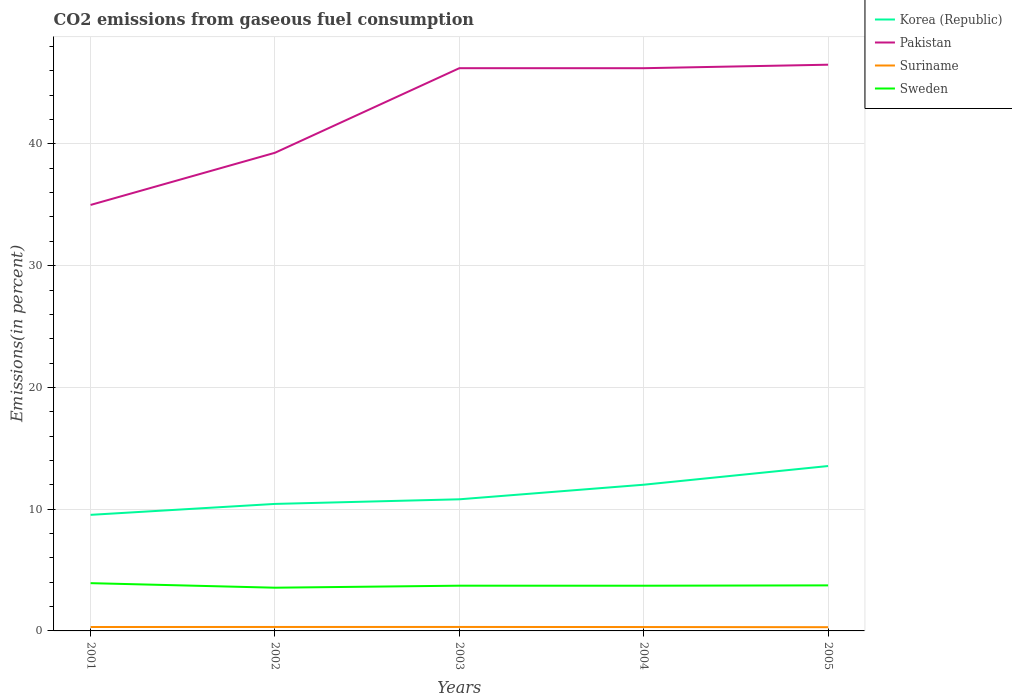How many different coloured lines are there?
Provide a short and direct response. 4. Does the line corresponding to Korea (Republic) intersect with the line corresponding to Suriname?
Provide a short and direct response. No. Across all years, what is the maximum total CO2 emitted in Korea (Republic)?
Keep it short and to the point. 9.53. What is the total total CO2 emitted in Pakistan in the graph?
Your answer should be very brief. -0.29. What is the difference between the highest and the second highest total CO2 emitted in Suriname?
Provide a succinct answer. 0.02. What is the difference between two consecutive major ticks on the Y-axis?
Offer a terse response. 10. Does the graph contain any zero values?
Provide a short and direct response. No. Where does the legend appear in the graph?
Your answer should be compact. Top right. How are the legend labels stacked?
Give a very brief answer. Vertical. What is the title of the graph?
Provide a short and direct response. CO2 emissions from gaseous fuel consumption. Does "Central African Republic" appear as one of the legend labels in the graph?
Your response must be concise. No. What is the label or title of the X-axis?
Offer a terse response. Years. What is the label or title of the Y-axis?
Your response must be concise. Emissions(in percent). What is the Emissions(in percent) of Korea (Republic) in 2001?
Give a very brief answer. 9.53. What is the Emissions(in percent) in Pakistan in 2001?
Your answer should be compact. 34.99. What is the Emissions(in percent) in Suriname in 2001?
Your answer should be very brief. 0.32. What is the Emissions(in percent) in Sweden in 2001?
Keep it short and to the point. 3.92. What is the Emissions(in percent) of Korea (Republic) in 2002?
Offer a terse response. 10.43. What is the Emissions(in percent) in Pakistan in 2002?
Your answer should be compact. 39.28. What is the Emissions(in percent) of Suriname in 2002?
Provide a succinct answer. 0.32. What is the Emissions(in percent) in Sweden in 2002?
Offer a very short reply. 3.55. What is the Emissions(in percent) of Korea (Republic) in 2003?
Keep it short and to the point. 10.81. What is the Emissions(in percent) in Pakistan in 2003?
Your answer should be very brief. 46.22. What is the Emissions(in percent) in Suriname in 2003?
Your answer should be compact. 0.33. What is the Emissions(in percent) of Sweden in 2003?
Offer a very short reply. 3.72. What is the Emissions(in percent) in Korea (Republic) in 2004?
Provide a succinct answer. 12.01. What is the Emissions(in percent) in Pakistan in 2004?
Provide a short and direct response. 46.22. What is the Emissions(in percent) in Suriname in 2004?
Provide a short and direct response. 0.32. What is the Emissions(in percent) in Sweden in 2004?
Your answer should be very brief. 3.71. What is the Emissions(in percent) of Korea (Republic) in 2005?
Give a very brief answer. 13.54. What is the Emissions(in percent) in Pakistan in 2005?
Make the answer very short. 46.51. What is the Emissions(in percent) in Suriname in 2005?
Your response must be concise. 0.31. What is the Emissions(in percent) of Sweden in 2005?
Provide a short and direct response. 3.74. Across all years, what is the maximum Emissions(in percent) of Korea (Republic)?
Offer a very short reply. 13.54. Across all years, what is the maximum Emissions(in percent) in Pakistan?
Your response must be concise. 46.51. Across all years, what is the maximum Emissions(in percent) of Suriname?
Keep it short and to the point. 0.33. Across all years, what is the maximum Emissions(in percent) of Sweden?
Provide a short and direct response. 3.92. Across all years, what is the minimum Emissions(in percent) of Korea (Republic)?
Provide a succinct answer. 9.53. Across all years, what is the minimum Emissions(in percent) in Pakistan?
Your answer should be compact. 34.99. Across all years, what is the minimum Emissions(in percent) in Suriname?
Give a very brief answer. 0.31. Across all years, what is the minimum Emissions(in percent) in Sweden?
Ensure brevity in your answer.  3.55. What is the total Emissions(in percent) of Korea (Republic) in the graph?
Your response must be concise. 56.33. What is the total Emissions(in percent) of Pakistan in the graph?
Provide a succinct answer. 213.22. What is the total Emissions(in percent) in Suriname in the graph?
Your answer should be very brief. 1.6. What is the total Emissions(in percent) in Sweden in the graph?
Provide a short and direct response. 18.64. What is the difference between the Emissions(in percent) in Korea (Republic) in 2001 and that in 2002?
Ensure brevity in your answer.  -0.9. What is the difference between the Emissions(in percent) of Pakistan in 2001 and that in 2002?
Offer a terse response. -4.29. What is the difference between the Emissions(in percent) of Suriname in 2001 and that in 2002?
Offer a terse response. -0. What is the difference between the Emissions(in percent) of Sweden in 2001 and that in 2002?
Provide a short and direct response. 0.37. What is the difference between the Emissions(in percent) of Korea (Republic) in 2001 and that in 2003?
Provide a succinct answer. -1.28. What is the difference between the Emissions(in percent) of Pakistan in 2001 and that in 2003?
Your answer should be very brief. -11.23. What is the difference between the Emissions(in percent) of Suriname in 2001 and that in 2003?
Offer a very short reply. -0. What is the difference between the Emissions(in percent) of Sweden in 2001 and that in 2003?
Keep it short and to the point. 0.21. What is the difference between the Emissions(in percent) of Korea (Republic) in 2001 and that in 2004?
Provide a short and direct response. -2.47. What is the difference between the Emissions(in percent) of Pakistan in 2001 and that in 2004?
Provide a succinct answer. -11.23. What is the difference between the Emissions(in percent) in Suriname in 2001 and that in 2004?
Your answer should be very brief. 0. What is the difference between the Emissions(in percent) in Sweden in 2001 and that in 2004?
Your answer should be compact. 0.21. What is the difference between the Emissions(in percent) in Korea (Republic) in 2001 and that in 2005?
Ensure brevity in your answer.  -4.01. What is the difference between the Emissions(in percent) in Pakistan in 2001 and that in 2005?
Give a very brief answer. -11.52. What is the difference between the Emissions(in percent) in Suriname in 2001 and that in 2005?
Keep it short and to the point. 0.02. What is the difference between the Emissions(in percent) of Sweden in 2001 and that in 2005?
Your answer should be compact. 0.18. What is the difference between the Emissions(in percent) of Korea (Republic) in 2002 and that in 2003?
Provide a succinct answer. -0.38. What is the difference between the Emissions(in percent) of Pakistan in 2002 and that in 2003?
Ensure brevity in your answer.  -6.95. What is the difference between the Emissions(in percent) in Suriname in 2002 and that in 2003?
Provide a short and direct response. -0. What is the difference between the Emissions(in percent) of Sweden in 2002 and that in 2003?
Your answer should be compact. -0.16. What is the difference between the Emissions(in percent) of Korea (Republic) in 2002 and that in 2004?
Your answer should be very brief. -1.58. What is the difference between the Emissions(in percent) in Pakistan in 2002 and that in 2004?
Provide a short and direct response. -6.95. What is the difference between the Emissions(in percent) in Suriname in 2002 and that in 2004?
Ensure brevity in your answer.  0.01. What is the difference between the Emissions(in percent) in Sweden in 2002 and that in 2004?
Keep it short and to the point. -0.16. What is the difference between the Emissions(in percent) of Korea (Republic) in 2002 and that in 2005?
Keep it short and to the point. -3.11. What is the difference between the Emissions(in percent) in Pakistan in 2002 and that in 2005?
Keep it short and to the point. -7.23. What is the difference between the Emissions(in percent) in Suriname in 2002 and that in 2005?
Offer a terse response. 0.02. What is the difference between the Emissions(in percent) of Sweden in 2002 and that in 2005?
Provide a succinct answer. -0.19. What is the difference between the Emissions(in percent) in Korea (Republic) in 2003 and that in 2004?
Ensure brevity in your answer.  -1.2. What is the difference between the Emissions(in percent) of Pakistan in 2003 and that in 2004?
Offer a very short reply. 0. What is the difference between the Emissions(in percent) in Suriname in 2003 and that in 2004?
Your answer should be compact. 0.01. What is the difference between the Emissions(in percent) in Sweden in 2003 and that in 2004?
Provide a succinct answer. 0. What is the difference between the Emissions(in percent) in Korea (Republic) in 2003 and that in 2005?
Offer a terse response. -2.73. What is the difference between the Emissions(in percent) in Pakistan in 2003 and that in 2005?
Offer a terse response. -0.29. What is the difference between the Emissions(in percent) in Suriname in 2003 and that in 2005?
Provide a short and direct response. 0.02. What is the difference between the Emissions(in percent) in Sweden in 2003 and that in 2005?
Your answer should be compact. -0.03. What is the difference between the Emissions(in percent) of Korea (Republic) in 2004 and that in 2005?
Your answer should be very brief. -1.53. What is the difference between the Emissions(in percent) in Pakistan in 2004 and that in 2005?
Give a very brief answer. -0.29. What is the difference between the Emissions(in percent) in Suriname in 2004 and that in 2005?
Make the answer very short. 0.01. What is the difference between the Emissions(in percent) in Sweden in 2004 and that in 2005?
Give a very brief answer. -0.03. What is the difference between the Emissions(in percent) of Korea (Republic) in 2001 and the Emissions(in percent) of Pakistan in 2002?
Offer a terse response. -29.74. What is the difference between the Emissions(in percent) in Korea (Republic) in 2001 and the Emissions(in percent) in Suriname in 2002?
Offer a very short reply. 9.21. What is the difference between the Emissions(in percent) of Korea (Republic) in 2001 and the Emissions(in percent) of Sweden in 2002?
Your response must be concise. 5.98. What is the difference between the Emissions(in percent) of Pakistan in 2001 and the Emissions(in percent) of Suriname in 2002?
Give a very brief answer. 34.66. What is the difference between the Emissions(in percent) in Pakistan in 2001 and the Emissions(in percent) in Sweden in 2002?
Your response must be concise. 31.44. What is the difference between the Emissions(in percent) in Suriname in 2001 and the Emissions(in percent) in Sweden in 2002?
Your response must be concise. -3.23. What is the difference between the Emissions(in percent) of Korea (Republic) in 2001 and the Emissions(in percent) of Pakistan in 2003?
Provide a succinct answer. -36.69. What is the difference between the Emissions(in percent) of Korea (Republic) in 2001 and the Emissions(in percent) of Suriname in 2003?
Provide a succinct answer. 9.21. What is the difference between the Emissions(in percent) of Korea (Republic) in 2001 and the Emissions(in percent) of Sweden in 2003?
Keep it short and to the point. 5.82. What is the difference between the Emissions(in percent) of Pakistan in 2001 and the Emissions(in percent) of Suriname in 2003?
Provide a short and direct response. 34.66. What is the difference between the Emissions(in percent) in Pakistan in 2001 and the Emissions(in percent) in Sweden in 2003?
Your answer should be compact. 31.27. What is the difference between the Emissions(in percent) of Suriname in 2001 and the Emissions(in percent) of Sweden in 2003?
Your answer should be very brief. -3.39. What is the difference between the Emissions(in percent) in Korea (Republic) in 2001 and the Emissions(in percent) in Pakistan in 2004?
Your answer should be very brief. -36.69. What is the difference between the Emissions(in percent) of Korea (Republic) in 2001 and the Emissions(in percent) of Suriname in 2004?
Provide a succinct answer. 9.22. What is the difference between the Emissions(in percent) of Korea (Republic) in 2001 and the Emissions(in percent) of Sweden in 2004?
Make the answer very short. 5.82. What is the difference between the Emissions(in percent) of Pakistan in 2001 and the Emissions(in percent) of Suriname in 2004?
Offer a very short reply. 34.67. What is the difference between the Emissions(in percent) in Pakistan in 2001 and the Emissions(in percent) in Sweden in 2004?
Your response must be concise. 31.28. What is the difference between the Emissions(in percent) of Suriname in 2001 and the Emissions(in percent) of Sweden in 2004?
Provide a short and direct response. -3.39. What is the difference between the Emissions(in percent) of Korea (Republic) in 2001 and the Emissions(in percent) of Pakistan in 2005?
Keep it short and to the point. -36.97. What is the difference between the Emissions(in percent) in Korea (Republic) in 2001 and the Emissions(in percent) in Suriname in 2005?
Keep it short and to the point. 9.23. What is the difference between the Emissions(in percent) of Korea (Republic) in 2001 and the Emissions(in percent) of Sweden in 2005?
Your answer should be compact. 5.79. What is the difference between the Emissions(in percent) of Pakistan in 2001 and the Emissions(in percent) of Suriname in 2005?
Provide a succinct answer. 34.68. What is the difference between the Emissions(in percent) of Pakistan in 2001 and the Emissions(in percent) of Sweden in 2005?
Provide a short and direct response. 31.25. What is the difference between the Emissions(in percent) in Suriname in 2001 and the Emissions(in percent) in Sweden in 2005?
Ensure brevity in your answer.  -3.42. What is the difference between the Emissions(in percent) in Korea (Republic) in 2002 and the Emissions(in percent) in Pakistan in 2003?
Your response must be concise. -35.79. What is the difference between the Emissions(in percent) of Korea (Republic) in 2002 and the Emissions(in percent) of Suriname in 2003?
Your answer should be compact. 10.11. What is the difference between the Emissions(in percent) of Korea (Republic) in 2002 and the Emissions(in percent) of Sweden in 2003?
Keep it short and to the point. 6.72. What is the difference between the Emissions(in percent) of Pakistan in 2002 and the Emissions(in percent) of Suriname in 2003?
Offer a terse response. 38.95. What is the difference between the Emissions(in percent) of Pakistan in 2002 and the Emissions(in percent) of Sweden in 2003?
Provide a short and direct response. 35.56. What is the difference between the Emissions(in percent) in Suriname in 2002 and the Emissions(in percent) in Sweden in 2003?
Offer a very short reply. -3.39. What is the difference between the Emissions(in percent) in Korea (Republic) in 2002 and the Emissions(in percent) in Pakistan in 2004?
Make the answer very short. -35.79. What is the difference between the Emissions(in percent) in Korea (Republic) in 2002 and the Emissions(in percent) in Suriname in 2004?
Give a very brief answer. 10.11. What is the difference between the Emissions(in percent) in Korea (Republic) in 2002 and the Emissions(in percent) in Sweden in 2004?
Give a very brief answer. 6.72. What is the difference between the Emissions(in percent) in Pakistan in 2002 and the Emissions(in percent) in Suriname in 2004?
Offer a very short reply. 38.96. What is the difference between the Emissions(in percent) of Pakistan in 2002 and the Emissions(in percent) of Sweden in 2004?
Offer a very short reply. 35.56. What is the difference between the Emissions(in percent) of Suriname in 2002 and the Emissions(in percent) of Sweden in 2004?
Make the answer very short. -3.39. What is the difference between the Emissions(in percent) of Korea (Republic) in 2002 and the Emissions(in percent) of Pakistan in 2005?
Offer a terse response. -36.08. What is the difference between the Emissions(in percent) in Korea (Republic) in 2002 and the Emissions(in percent) in Suriname in 2005?
Make the answer very short. 10.13. What is the difference between the Emissions(in percent) of Korea (Republic) in 2002 and the Emissions(in percent) of Sweden in 2005?
Make the answer very short. 6.69. What is the difference between the Emissions(in percent) in Pakistan in 2002 and the Emissions(in percent) in Suriname in 2005?
Ensure brevity in your answer.  38.97. What is the difference between the Emissions(in percent) of Pakistan in 2002 and the Emissions(in percent) of Sweden in 2005?
Your answer should be compact. 35.53. What is the difference between the Emissions(in percent) in Suriname in 2002 and the Emissions(in percent) in Sweden in 2005?
Offer a very short reply. -3.42. What is the difference between the Emissions(in percent) of Korea (Republic) in 2003 and the Emissions(in percent) of Pakistan in 2004?
Your answer should be compact. -35.41. What is the difference between the Emissions(in percent) in Korea (Republic) in 2003 and the Emissions(in percent) in Suriname in 2004?
Your answer should be very brief. 10.49. What is the difference between the Emissions(in percent) of Korea (Republic) in 2003 and the Emissions(in percent) of Sweden in 2004?
Your answer should be very brief. 7.1. What is the difference between the Emissions(in percent) in Pakistan in 2003 and the Emissions(in percent) in Suriname in 2004?
Provide a short and direct response. 45.9. What is the difference between the Emissions(in percent) of Pakistan in 2003 and the Emissions(in percent) of Sweden in 2004?
Provide a succinct answer. 42.51. What is the difference between the Emissions(in percent) in Suriname in 2003 and the Emissions(in percent) in Sweden in 2004?
Provide a short and direct response. -3.39. What is the difference between the Emissions(in percent) in Korea (Republic) in 2003 and the Emissions(in percent) in Pakistan in 2005?
Provide a succinct answer. -35.7. What is the difference between the Emissions(in percent) of Korea (Republic) in 2003 and the Emissions(in percent) of Suriname in 2005?
Your answer should be very brief. 10.5. What is the difference between the Emissions(in percent) in Korea (Republic) in 2003 and the Emissions(in percent) in Sweden in 2005?
Keep it short and to the point. 7.07. What is the difference between the Emissions(in percent) of Pakistan in 2003 and the Emissions(in percent) of Suriname in 2005?
Provide a succinct answer. 45.92. What is the difference between the Emissions(in percent) in Pakistan in 2003 and the Emissions(in percent) in Sweden in 2005?
Provide a short and direct response. 42.48. What is the difference between the Emissions(in percent) in Suriname in 2003 and the Emissions(in percent) in Sweden in 2005?
Offer a very short reply. -3.41. What is the difference between the Emissions(in percent) in Korea (Republic) in 2004 and the Emissions(in percent) in Pakistan in 2005?
Keep it short and to the point. -34.5. What is the difference between the Emissions(in percent) of Korea (Republic) in 2004 and the Emissions(in percent) of Suriname in 2005?
Provide a short and direct response. 11.7. What is the difference between the Emissions(in percent) of Korea (Republic) in 2004 and the Emissions(in percent) of Sweden in 2005?
Make the answer very short. 8.27. What is the difference between the Emissions(in percent) in Pakistan in 2004 and the Emissions(in percent) in Suriname in 2005?
Make the answer very short. 45.91. What is the difference between the Emissions(in percent) in Pakistan in 2004 and the Emissions(in percent) in Sweden in 2005?
Give a very brief answer. 42.48. What is the difference between the Emissions(in percent) of Suriname in 2004 and the Emissions(in percent) of Sweden in 2005?
Your response must be concise. -3.42. What is the average Emissions(in percent) in Korea (Republic) per year?
Provide a short and direct response. 11.27. What is the average Emissions(in percent) of Pakistan per year?
Keep it short and to the point. 42.64. What is the average Emissions(in percent) of Suriname per year?
Offer a very short reply. 0.32. What is the average Emissions(in percent) of Sweden per year?
Make the answer very short. 3.73. In the year 2001, what is the difference between the Emissions(in percent) in Korea (Republic) and Emissions(in percent) in Pakistan?
Offer a very short reply. -25.45. In the year 2001, what is the difference between the Emissions(in percent) in Korea (Republic) and Emissions(in percent) in Suriname?
Provide a short and direct response. 9.21. In the year 2001, what is the difference between the Emissions(in percent) of Korea (Republic) and Emissions(in percent) of Sweden?
Your answer should be very brief. 5.61. In the year 2001, what is the difference between the Emissions(in percent) of Pakistan and Emissions(in percent) of Suriname?
Provide a short and direct response. 34.67. In the year 2001, what is the difference between the Emissions(in percent) in Pakistan and Emissions(in percent) in Sweden?
Give a very brief answer. 31.07. In the year 2001, what is the difference between the Emissions(in percent) of Suriname and Emissions(in percent) of Sweden?
Offer a very short reply. -3.6. In the year 2002, what is the difference between the Emissions(in percent) in Korea (Republic) and Emissions(in percent) in Pakistan?
Give a very brief answer. -28.84. In the year 2002, what is the difference between the Emissions(in percent) in Korea (Republic) and Emissions(in percent) in Suriname?
Provide a succinct answer. 10.11. In the year 2002, what is the difference between the Emissions(in percent) in Korea (Republic) and Emissions(in percent) in Sweden?
Your answer should be very brief. 6.88. In the year 2002, what is the difference between the Emissions(in percent) in Pakistan and Emissions(in percent) in Suriname?
Your response must be concise. 38.95. In the year 2002, what is the difference between the Emissions(in percent) in Pakistan and Emissions(in percent) in Sweden?
Your answer should be compact. 35.73. In the year 2002, what is the difference between the Emissions(in percent) in Suriname and Emissions(in percent) in Sweden?
Provide a short and direct response. -3.23. In the year 2003, what is the difference between the Emissions(in percent) in Korea (Republic) and Emissions(in percent) in Pakistan?
Keep it short and to the point. -35.41. In the year 2003, what is the difference between the Emissions(in percent) of Korea (Republic) and Emissions(in percent) of Suriname?
Your response must be concise. 10.48. In the year 2003, what is the difference between the Emissions(in percent) of Korea (Republic) and Emissions(in percent) of Sweden?
Make the answer very short. 7.1. In the year 2003, what is the difference between the Emissions(in percent) of Pakistan and Emissions(in percent) of Suriname?
Keep it short and to the point. 45.9. In the year 2003, what is the difference between the Emissions(in percent) of Pakistan and Emissions(in percent) of Sweden?
Offer a terse response. 42.51. In the year 2003, what is the difference between the Emissions(in percent) in Suriname and Emissions(in percent) in Sweden?
Provide a short and direct response. -3.39. In the year 2004, what is the difference between the Emissions(in percent) of Korea (Republic) and Emissions(in percent) of Pakistan?
Your answer should be compact. -34.21. In the year 2004, what is the difference between the Emissions(in percent) in Korea (Republic) and Emissions(in percent) in Suriname?
Ensure brevity in your answer.  11.69. In the year 2004, what is the difference between the Emissions(in percent) in Korea (Republic) and Emissions(in percent) in Sweden?
Make the answer very short. 8.3. In the year 2004, what is the difference between the Emissions(in percent) of Pakistan and Emissions(in percent) of Suriname?
Ensure brevity in your answer.  45.9. In the year 2004, what is the difference between the Emissions(in percent) of Pakistan and Emissions(in percent) of Sweden?
Offer a terse response. 42.51. In the year 2004, what is the difference between the Emissions(in percent) in Suriname and Emissions(in percent) in Sweden?
Provide a succinct answer. -3.39. In the year 2005, what is the difference between the Emissions(in percent) in Korea (Republic) and Emissions(in percent) in Pakistan?
Provide a short and direct response. -32.97. In the year 2005, what is the difference between the Emissions(in percent) in Korea (Republic) and Emissions(in percent) in Suriname?
Offer a terse response. 13.24. In the year 2005, what is the difference between the Emissions(in percent) in Korea (Republic) and Emissions(in percent) in Sweden?
Give a very brief answer. 9.8. In the year 2005, what is the difference between the Emissions(in percent) in Pakistan and Emissions(in percent) in Suriname?
Make the answer very short. 46.2. In the year 2005, what is the difference between the Emissions(in percent) in Pakistan and Emissions(in percent) in Sweden?
Give a very brief answer. 42.77. In the year 2005, what is the difference between the Emissions(in percent) of Suriname and Emissions(in percent) of Sweden?
Your response must be concise. -3.43. What is the ratio of the Emissions(in percent) in Korea (Republic) in 2001 to that in 2002?
Provide a succinct answer. 0.91. What is the ratio of the Emissions(in percent) in Pakistan in 2001 to that in 2002?
Give a very brief answer. 0.89. What is the ratio of the Emissions(in percent) in Suriname in 2001 to that in 2002?
Ensure brevity in your answer.  0.99. What is the ratio of the Emissions(in percent) of Sweden in 2001 to that in 2002?
Provide a short and direct response. 1.1. What is the ratio of the Emissions(in percent) in Korea (Republic) in 2001 to that in 2003?
Your answer should be very brief. 0.88. What is the ratio of the Emissions(in percent) of Pakistan in 2001 to that in 2003?
Provide a short and direct response. 0.76. What is the ratio of the Emissions(in percent) in Suriname in 2001 to that in 2003?
Offer a terse response. 0.99. What is the ratio of the Emissions(in percent) of Sweden in 2001 to that in 2003?
Ensure brevity in your answer.  1.06. What is the ratio of the Emissions(in percent) of Korea (Republic) in 2001 to that in 2004?
Provide a succinct answer. 0.79. What is the ratio of the Emissions(in percent) of Pakistan in 2001 to that in 2004?
Offer a very short reply. 0.76. What is the ratio of the Emissions(in percent) in Suriname in 2001 to that in 2004?
Your response must be concise. 1.01. What is the ratio of the Emissions(in percent) in Sweden in 2001 to that in 2004?
Offer a very short reply. 1.06. What is the ratio of the Emissions(in percent) in Korea (Republic) in 2001 to that in 2005?
Your response must be concise. 0.7. What is the ratio of the Emissions(in percent) in Pakistan in 2001 to that in 2005?
Your response must be concise. 0.75. What is the ratio of the Emissions(in percent) in Sweden in 2001 to that in 2005?
Make the answer very short. 1.05. What is the ratio of the Emissions(in percent) in Korea (Republic) in 2002 to that in 2003?
Keep it short and to the point. 0.96. What is the ratio of the Emissions(in percent) in Pakistan in 2002 to that in 2003?
Offer a very short reply. 0.85. What is the ratio of the Emissions(in percent) of Sweden in 2002 to that in 2003?
Offer a very short reply. 0.96. What is the ratio of the Emissions(in percent) of Korea (Republic) in 2002 to that in 2004?
Make the answer very short. 0.87. What is the ratio of the Emissions(in percent) in Pakistan in 2002 to that in 2004?
Ensure brevity in your answer.  0.85. What is the ratio of the Emissions(in percent) in Suriname in 2002 to that in 2004?
Keep it short and to the point. 1.02. What is the ratio of the Emissions(in percent) of Sweden in 2002 to that in 2004?
Provide a short and direct response. 0.96. What is the ratio of the Emissions(in percent) of Korea (Republic) in 2002 to that in 2005?
Provide a succinct answer. 0.77. What is the ratio of the Emissions(in percent) of Pakistan in 2002 to that in 2005?
Offer a very short reply. 0.84. What is the ratio of the Emissions(in percent) of Suriname in 2002 to that in 2005?
Your answer should be very brief. 1.06. What is the ratio of the Emissions(in percent) in Sweden in 2002 to that in 2005?
Provide a short and direct response. 0.95. What is the ratio of the Emissions(in percent) in Korea (Republic) in 2003 to that in 2004?
Make the answer very short. 0.9. What is the ratio of the Emissions(in percent) of Suriname in 2003 to that in 2004?
Provide a succinct answer. 1.02. What is the ratio of the Emissions(in percent) of Korea (Republic) in 2003 to that in 2005?
Offer a very short reply. 0.8. What is the ratio of the Emissions(in percent) of Pakistan in 2003 to that in 2005?
Your response must be concise. 0.99. What is the ratio of the Emissions(in percent) in Suriname in 2003 to that in 2005?
Ensure brevity in your answer.  1.06. What is the ratio of the Emissions(in percent) of Korea (Republic) in 2004 to that in 2005?
Your response must be concise. 0.89. What is the ratio of the Emissions(in percent) of Suriname in 2004 to that in 2005?
Make the answer very short. 1.04. What is the difference between the highest and the second highest Emissions(in percent) in Korea (Republic)?
Your response must be concise. 1.53. What is the difference between the highest and the second highest Emissions(in percent) in Pakistan?
Your answer should be compact. 0.29. What is the difference between the highest and the second highest Emissions(in percent) in Suriname?
Your answer should be very brief. 0. What is the difference between the highest and the second highest Emissions(in percent) of Sweden?
Offer a very short reply. 0.18. What is the difference between the highest and the lowest Emissions(in percent) of Korea (Republic)?
Keep it short and to the point. 4.01. What is the difference between the highest and the lowest Emissions(in percent) of Pakistan?
Offer a terse response. 11.52. What is the difference between the highest and the lowest Emissions(in percent) of Suriname?
Provide a short and direct response. 0.02. What is the difference between the highest and the lowest Emissions(in percent) of Sweden?
Make the answer very short. 0.37. 